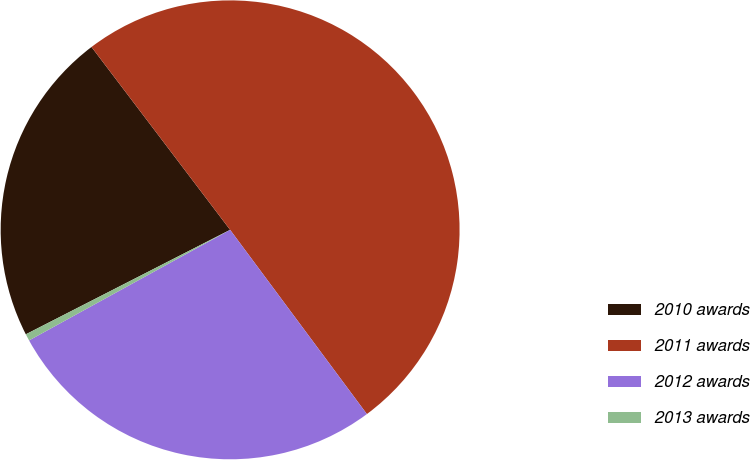<chart> <loc_0><loc_0><loc_500><loc_500><pie_chart><fcel>2010 awards<fcel>2011 awards<fcel>2012 awards<fcel>2013 awards<nl><fcel>22.2%<fcel>50.16%<fcel>27.16%<fcel>0.48%<nl></chart> 